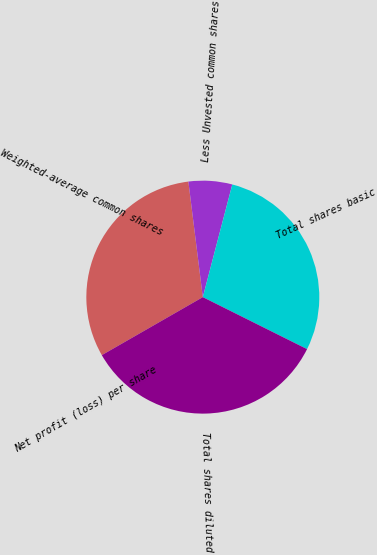Convert chart to OTSL. <chart><loc_0><loc_0><loc_500><loc_500><pie_chart><fcel>Weighted-average common shares<fcel>Less Unvested common shares<fcel>Total shares basic<fcel>Total shares diluted<fcel>Net profit (loss) per share<nl><fcel>31.32%<fcel>6.05%<fcel>28.29%<fcel>34.34%<fcel>0.0%<nl></chart> 